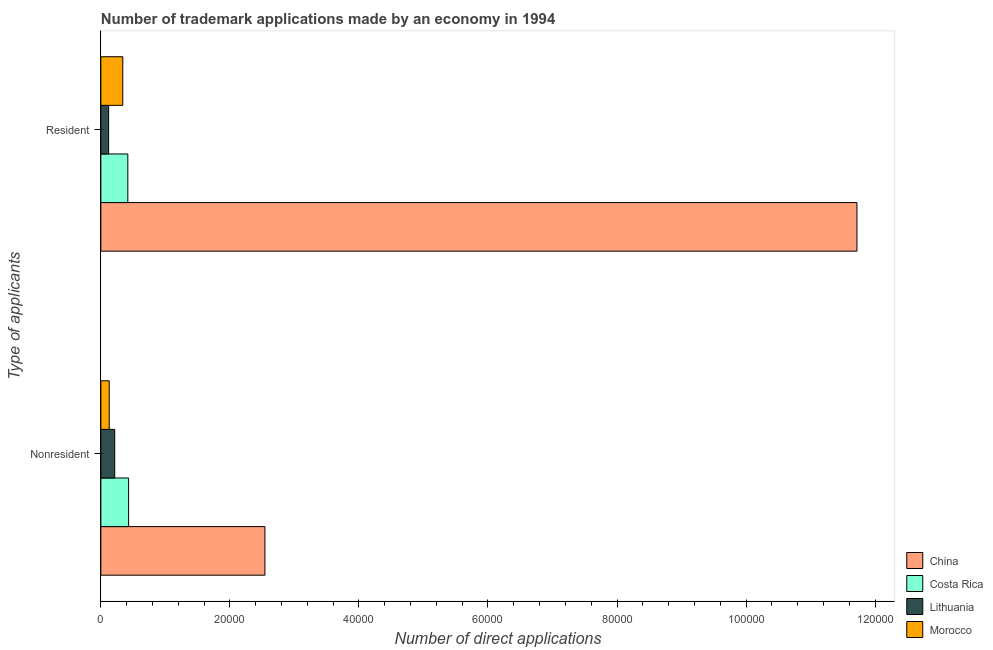How many different coloured bars are there?
Offer a terse response. 4. Are the number of bars per tick equal to the number of legend labels?
Ensure brevity in your answer.  Yes. What is the label of the 1st group of bars from the top?
Keep it short and to the point. Resident. What is the number of trademark applications made by non residents in Costa Rica?
Keep it short and to the point. 4305. Across all countries, what is the maximum number of trademark applications made by residents?
Offer a terse response. 1.17e+05. Across all countries, what is the minimum number of trademark applications made by residents?
Your answer should be very brief. 1206. In which country was the number of trademark applications made by residents minimum?
Provide a short and direct response. Lithuania. What is the total number of trademark applications made by non residents in the graph?
Keep it short and to the point. 3.32e+04. What is the difference between the number of trademark applications made by residents in Costa Rica and that in China?
Your response must be concise. -1.13e+05. What is the difference between the number of trademark applications made by non residents in Morocco and the number of trademark applications made by residents in China?
Give a very brief answer. -1.16e+05. What is the average number of trademark applications made by residents per country?
Ensure brevity in your answer.  3.15e+04. What is the difference between the number of trademark applications made by residents and number of trademark applications made by non residents in Costa Rica?
Your response must be concise. -122. In how many countries, is the number of trademark applications made by non residents greater than 72000 ?
Your answer should be compact. 0. What is the ratio of the number of trademark applications made by residents in China to that in Costa Rica?
Provide a short and direct response. 28.01. Is the number of trademark applications made by residents in Lithuania less than that in Costa Rica?
Make the answer very short. Yes. In how many countries, is the number of trademark applications made by residents greater than the average number of trademark applications made by residents taken over all countries?
Keep it short and to the point. 1. What does the 1st bar from the top in Resident represents?
Your answer should be compact. Morocco. What does the 1st bar from the bottom in Resident represents?
Ensure brevity in your answer.  China. Are all the bars in the graph horizontal?
Give a very brief answer. Yes. What is the difference between two consecutive major ticks on the X-axis?
Your answer should be very brief. 2.00e+04. Are the values on the major ticks of X-axis written in scientific E-notation?
Your response must be concise. No. Does the graph contain any zero values?
Provide a succinct answer. No. Where does the legend appear in the graph?
Your response must be concise. Bottom right. How are the legend labels stacked?
Provide a short and direct response. Vertical. What is the title of the graph?
Your answer should be very brief. Number of trademark applications made by an economy in 1994. Does "Serbia" appear as one of the legend labels in the graph?
Provide a short and direct response. No. What is the label or title of the X-axis?
Keep it short and to the point. Number of direct applications. What is the label or title of the Y-axis?
Your answer should be very brief. Type of applicants. What is the Number of direct applications of China in Nonresident?
Provide a succinct answer. 2.54e+04. What is the Number of direct applications of Costa Rica in Nonresident?
Provide a short and direct response. 4305. What is the Number of direct applications in Lithuania in Nonresident?
Give a very brief answer. 2153. What is the Number of direct applications in Morocco in Nonresident?
Offer a very short reply. 1299. What is the Number of direct applications in China in Resident?
Offer a very short reply. 1.17e+05. What is the Number of direct applications of Costa Rica in Resident?
Offer a terse response. 4183. What is the Number of direct applications of Lithuania in Resident?
Your answer should be compact. 1206. What is the Number of direct applications in Morocco in Resident?
Your response must be concise. 3403. Across all Type of applicants, what is the maximum Number of direct applications in China?
Provide a succinct answer. 1.17e+05. Across all Type of applicants, what is the maximum Number of direct applications in Costa Rica?
Keep it short and to the point. 4305. Across all Type of applicants, what is the maximum Number of direct applications of Lithuania?
Provide a short and direct response. 2153. Across all Type of applicants, what is the maximum Number of direct applications of Morocco?
Your response must be concise. 3403. Across all Type of applicants, what is the minimum Number of direct applications of China?
Make the answer very short. 2.54e+04. Across all Type of applicants, what is the minimum Number of direct applications of Costa Rica?
Give a very brief answer. 4183. Across all Type of applicants, what is the minimum Number of direct applications of Lithuania?
Provide a short and direct response. 1206. Across all Type of applicants, what is the minimum Number of direct applications in Morocco?
Make the answer very short. 1299. What is the total Number of direct applications in China in the graph?
Your answer should be very brief. 1.43e+05. What is the total Number of direct applications of Costa Rica in the graph?
Give a very brief answer. 8488. What is the total Number of direct applications of Lithuania in the graph?
Offer a terse response. 3359. What is the total Number of direct applications in Morocco in the graph?
Give a very brief answer. 4702. What is the difference between the Number of direct applications in China in Nonresident and that in Resident?
Offer a terse response. -9.18e+04. What is the difference between the Number of direct applications of Costa Rica in Nonresident and that in Resident?
Offer a terse response. 122. What is the difference between the Number of direct applications of Lithuania in Nonresident and that in Resident?
Offer a very short reply. 947. What is the difference between the Number of direct applications in Morocco in Nonresident and that in Resident?
Keep it short and to the point. -2104. What is the difference between the Number of direct applications of China in Nonresident and the Number of direct applications of Costa Rica in Resident?
Ensure brevity in your answer.  2.12e+04. What is the difference between the Number of direct applications of China in Nonresident and the Number of direct applications of Lithuania in Resident?
Your answer should be compact. 2.42e+04. What is the difference between the Number of direct applications of China in Nonresident and the Number of direct applications of Morocco in Resident?
Your answer should be compact. 2.20e+04. What is the difference between the Number of direct applications in Costa Rica in Nonresident and the Number of direct applications in Lithuania in Resident?
Provide a short and direct response. 3099. What is the difference between the Number of direct applications in Costa Rica in Nonresident and the Number of direct applications in Morocco in Resident?
Ensure brevity in your answer.  902. What is the difference between the Number of direct applications of Lithuania in Nonresident and the Number of direct applications of Morocco in Resident?
Ensure brevity in your answer.  -1250. What is the average Number of direct applications in China per Type of applicants?
Offer a terse response. 7.13e+04. What is the average Number of direct applications in Costa Rica per Type of applicants?
Give a very brief answer. 4244. What is the average Number of direct applications in Lithuania per Type of applicants?
Your response must be concise. 1679.5. What is the average Number of direct applications of Morocco per Type of applicants?
Offer a very short reply. 2351. What is the difference between the Number of direct applications of China and Number of direct applications of Costa Rica in Nonresident?
Ensure brevity in your answer.  2.11e+04. What is the difference between the Number of direct applications of China and Number of direct applications of Lithuania in Nonresident?
Provide a short and direct response. 2.33e+04. What is the difference between the Number of direct applications in China and Number of direct applications in Morocco in Nonresident?
Your response must be concise. 2.41e+04. What is the difference between the Number of direct applications in Costa Rica and Number of direct applications in Lithuania in Nonresident?
Your answer should be compact. 2152. What is the difference between the Number of direct applications of Costa Rica and Number of direct applications of Morocco in Nonresident?
Provide a succinct answer. 3006. What is the difference between the Number of direct applications of Lithuania and Number of direct applications of Morocco in Nonresident?
Make the answer very short. 854. What is the difference between the Number of direct applications of China and Number of direct applications of Costa Rica in Resident?
Provide a succinct answer. 1.13e+05. What is the difference between the Number of direct applications of China and Number of direct applications of Lithuania in Resident?
Offer a very short reply. 1.16e+05. What is the difference between the Number of direct applications of China and Number of direct applications of Morocco in Resident?
Ensure brevity in your answer.  1.14e+05. What is the difference between the Number of direct applications in Costa Rica and Number of direct applications in Lithuania in Resident?
Keep it short and to the point. 2977. What is the difference between the Number of direct applications in Costa Rica and Number of direct applications in Morocco in Resident?
Your response must be concise. 780. What is the difference between the Number of direct applications of Lithuania and Number of direct applications of Morocco in Resident?
Your response must be concise. -2197. What is the ratio of the Number of direct applications in China in Nonresident to that in Resident?
Make the answer very short. 0.22. What is the ratio of the Number of direct applications of Costa Rica in Nonresident to that in Resident?
Offer a very short reply. 1.03. What is the ratio of the Number of direct applications of Lithuania in Nonresident to that in Resident?
Give a very brief answer. 1.79. What is the ratio of the Number of direct applications in Morocco in Nonresident to that in Resident?
Provide a succinct answer. 0.38. What is the difference between the highest and the second highest Number of direct applications in China?
Ensure brevity in your answer.  9.18e+04. What is the difference between the highest and the second highest Number of direct applications in Costa Rica?
Ensure brevity in your answer.  122. What is the difference between the highest and the second highest Number of direct applications of Lithuania?
Your answer should be compact. 947. What is the difference between the highest and the second highest Number of direct applications in Morocco?
Give a very brief answer. 2104. What is the difference between the highest and the lowest Number of direct applications in China?
Your answer should be compact. 9.18e+04. What is the difference between the highest and the lowest Number of direct applications of Costa Rica?
Keep it short and to the point. 122. What is the difference between the highest and the lowest Number of direct applications in Lithuania?
Your answer should be very brief. 947. What is the difference between the highest and the lowest Number of direct applications of Morocco?
Offer a terse response. 2104. 